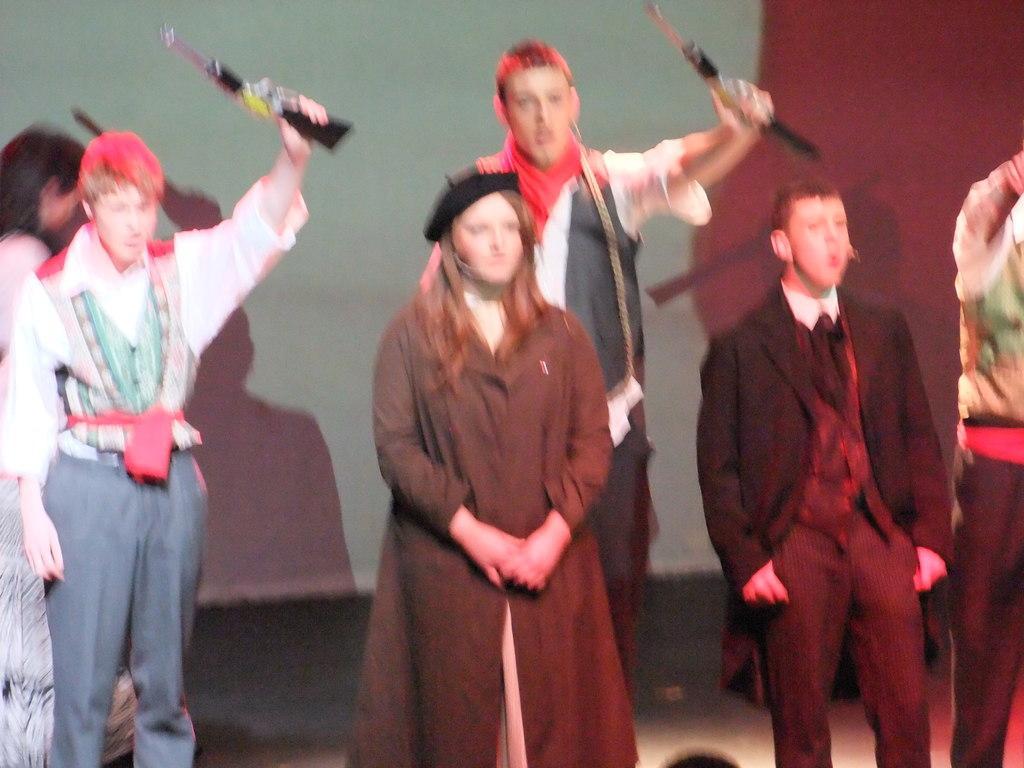How would you summarize this image in a sentence or two? In this picture there are two men standing and holding the objects and there are four people standing. At the back there is a screen and there are shadows of two people. At the bottom there is a floor. 